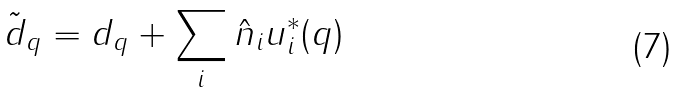<formula> <loc_0><loc_0><loc_500><loc_500>\tilde { d } _ { q } = d _ { q } + \sum _ { i } \hat { n } _ { i } u ^ { * } _ { i } ( { q } )</formula> 